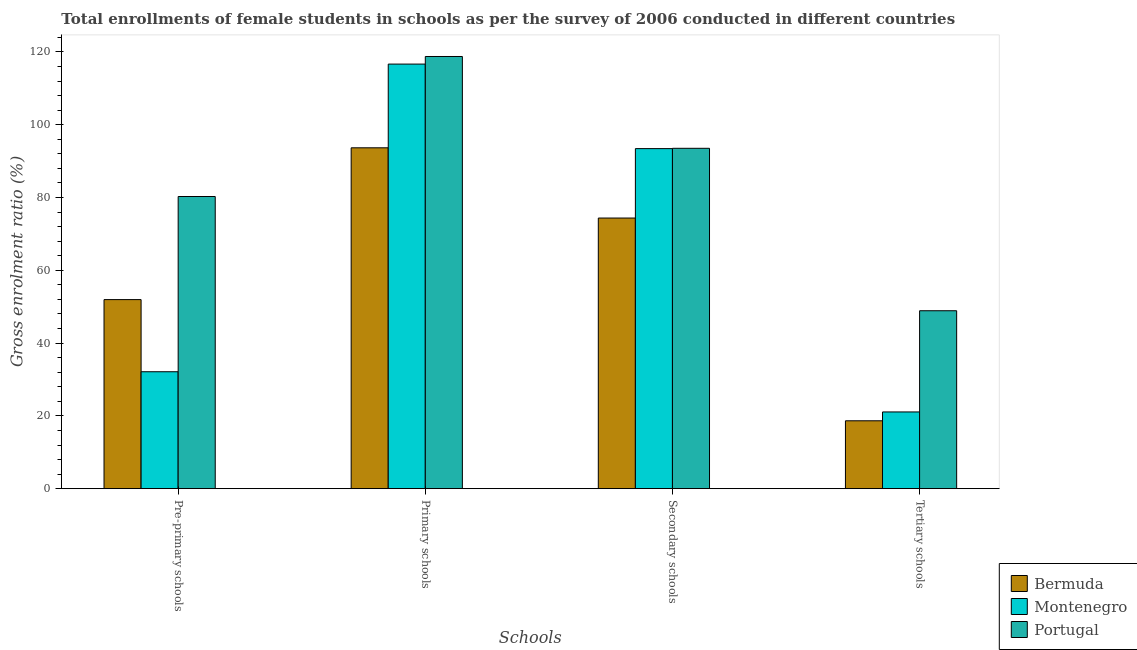How many different coloured bars are there?
Give a very brief answer. 3. How many bars are there on the 1st tick from the right?
Make the answer very short. 3. What is the label of the 2nd group of bars from the left?
Keep it short and to the point. Primary schools. What is the gross enrolment ratio(female) in pre-primary schools in Portugal?
Your response must be concise. 80.28. Across all countries, what is the maximum gross enrolment ratio(female) in pre-primary schools?
Your answer should be very brief. 80.28. Across all countries, what is the minimum gross enrolment ratio(female) in pre-primary schools?
Your answer should be compact. 32.13. In which country was the gross enrolment ratio(female) in pre-primary schools minimum?
Make the answer very short. Montenegro. What is the total gross enrolment ratio(female) in tertiary schools in the graph?
Ensure brevity in your answer.  88.63. What is the difference between the gross enrolment ratio(female) in primary schools in Portugal and that in Bermuda?
Provide a succinct answer. 25.09. What is the difference between the gross enrolment ratio(female) in tertiary schools in Bermuda and the gross enrolment ratio(female) in pre-primary schools in Portugal?
Provide a short and direct response. -61.63. What is the average gross enrolment ratio(female) in secondary schools per country?
Your response must be concise. 87.11. What is the difference between the gross enrolment ratio(female) in primary schools and gross enrolment ratio(female) in tertiary schools in Montenegro?
Your response must be concise. 95.58. In how many countries, is the gross enrolment ratio(female) in primary schools greater than 72 %?
Provide a succinct answer. 3. What is the ratio of the gross enrolment ratio(female) in tertiary schools in Bermuda to that in Montenegro?
Provide a succinct answer. 0.88. What is the difference between the highest and the second highest gross enrolment ratio(female) in tertiary schools?
Ensure brevity in your answer.  27.81. What is the difference between the highest and the lowest gross enrolment ratio(female) in secondary schools?
Make the answer very short. 19.16. In how many countries, is the gross enrolment ratio(female) in primary schools greater than the average gross enrolment ratio(female) in primary schools taken over all countries?
Ensure brevity in your answer.  2. Is the sum of the gross enrolment ratio(female) in tertiary schools in Bermuda and Portugal greater than the maximum gross enrolment ratio(female) in secondary schools across all countries?
Offer a very short reply. No. Is it the case that in every country, the sum of the gross enrolment ratio(female) in pre-primary schools and gross enrolment ratio(female) in secondary schools is greater than the sum of gross enrolment ratio(female) in tertiary schools and gross enrolment ratio(female) in primary schools?
Offer a very short reply. No. What does the 3rd bar from the left in Primary schools represents?
Your answer should be very brief. Portugal. What does the 1st bar from the right in Pre-primary schools represents?
Offer a terse response. Portugal. How many bars are there?
Make the answer very short. 12. Are all the bars in the graph horizontal?
Offer a very short reply. No. How many countries are there in the graph?
Give a very brief answer. 3. What is the difference between two consecutive major ticks on the Y-axis?
Make the answer very short. 20. Does the graph contain any zero values?
Offer a very short reply. No. Where does the legend appear in the graph?
Keep it short and to the point. Bottom right. What is the title of the graph?
Ensure brevity in your answer.  Total enrollments of female students in schools as per the survey of 2006 conducted in different countries. Does "Andorra" appear as one of the legend labels in the graph?
Ensure brevity in your answer.  No. What is the label or title of the X-axis?
Give a very brief answer. Schools. What is the label or title of the Y-axis?
Keep it short and to the point. Gross enrolment ratio (%). What is the Gross enrolment ratio (%) of Bermuda in Pre-primary schools?
Offer a terse response. 51.95. What is the Gross enrolment ratio (%) in Montenegro in Pre-primary schools?
Your answer should be very brief. 32.13. What is the Gross enrolment ratio (%) in Portugal in Pre-primary schools?
Offer a very short reply. 80.28. What is the Gross enrolment ratio (%) in Bermuda in Primary schools?
Make the answer very short. 93.66. What is the Gross enrolment ratio (%) in Montenegro in Primary schools?
Keep it short and to the point. 116.67. What is the Gross enrolment ratio (%) of Portugal in Primary schools?
Provide a succinct answer. 118.76. What is the Gross enrolment ratio (%) of Bermuda in Secondary schools?
Your response must be concise. 74.36. What is the Gross enrolment ratio (%) in Montenegro in Secondary schools?
Offer a very short reply. 93.44. What is the Gross enrolment ratio (%) of Portugal in Secondary schools?
Provide a succinct answer. 93.53. What is the Gross enrolment ratio (%) of Bermuda in Tertiary schools?
Provide a succinct answer. 18.65. What is the Gross enrolment ratio (%) in Montenegro in Tertiary schools?
Make the answer very short. 21.08. What is the Gross enrolment ratio (%) of Portugal in Tertiary schools?
Provide a short and direct response. 48.89. Across all Schools, what is the maximum Gross enrolment ratio (%) in Bermuda?
Your answer should be compact. 93.66. Across all Schools, what is the maximum Gross enrolment ratio (%) in Montenegro?
Keep it short and to the point. 116.67. Across all Schools, what is the maximum Gross enrolment ratio (%) of Portugal?
Give a very brief answer. 118.76. Across all Schools, what is the minimum Gross enrolment ratio (%) of Bermuda?
Offer a very short reply. 18.65. Across all Schools, what is the minimum Gross enrolment ratio (%) in Montenegro?
Provide a short and direct response. 21.08. Across all Schools, what is the minimum Gross enrolment ratio (%) of Portugal?
Provide a short and direct response. 48.89. What is the total Gross enrolment ratio (%) in Bermuda in the graph?
Your answer should be very brief. 238.63. What is the total Gross enrolment ratio (%) of Montenegro in the graph?
Provide a succinct answer. 263.32. What is the total Gross enrolment ratio (%) in Portugal in the graph?
Your answer should be compact. 341.45. What is the difference between the Gross enrolment ratio (%) of Bermuda in Pre-primary schools and that in Primary schools?
Your answer should be compact. -41.71. What is the difference between the Gross enrolment ratio (%) in Montenegro in Pre-primary schools and that in Primary schools?
Your response must be concise. -84.54. What is the difference between the Gross enrolment ratio (%) of Portugal in Pre-primary schools and that in Primary schools?
Provide a succinct answer. -38.47. What is the difference between the Gross enrolment ratio (%) of Bermuda in Pre-primary schools and that in Secondary schools?
Your response must be concise. -22.41. What is the difference between the Gross enrolment ratio (%) of Montenegro in Pre-primary schools and that in Secondary schools?
Ensure brevity in your answer.  -61.31. What is the difference between the Gross enrolment ratio (%) of Portugal in Pre-primary schools and that in Secondary schools?
Offer a very short reply. -13.24. What is the difference between the Gross enrolment ratio (%) of Bermuda in Pre-primary schools and that in Tertiary schools?
Your answer should be compact. 33.3. What is the difference between the Gross enrolment ratio (%) in Montenegro in Pre-primary schools and that in Tertiary schools?
Offer a terse response. 11.04. What is the difference between the Gross enrolment ratio (%) of Portugal in Pre-primary schools and that in Tertiary schools?
Offer a very short reply. 31.39. What is the difference between the Gross enrolment ratio (%) of Bermuda in Primary schools and that in Secondary schools?
Provide a succinct answer. 19.3. What is the difference between the Gross enrolment ratio (%) in Montenegro in Primary schools and that in Secondary schools?
Your answer should be very brief. 23.23. What is the difference between the Gross enrolment ratio (%) in Portugal in Primary schools and that in Secondary schools?
Ensure brevity in your answer.  25.23. What is the difference between the Gross enrolment ratio (%) in Bermuda in Primary schools and that in Tertiary schools?
Keep it short and to the point. 75.01. What is the difference between the Gross enrolment ratio (%) of Montenegro in Primary schools and that in Tertiary schools?
Make the answer very short. 95.58. What is the difference between the Gross enrolment ratio (%) of Portugal in Primary schools and that in Tertiary schools?
Give a very brief answer. 69.86. What is the difference between the Gross enrolment ratio (%) in Bermuda in Secondary schools and that in Tertiary schools?
Your answer should be compact. 55.71. What is the difference between the Gross enrolment ratio (%) of Montenegro in Secondary schools and that in Tertiary schools?
Your answer should be compact. 72.35. What is the difference between the Gross enrolment ratio (%) of Portugal in Secondary schools and that in Tertiary schools?
Ensure brevity in your answer.  44.63. What is the difference between the Gross enrolment ratio (%) of Bermuda in Pre-primary schools and the Gross enrolment ratio (%) of Montenegro in Primary schools?
Offer a terse response. -64.71. What is the difference between the Gross enrolment ratio (%) of Bermuda in Pre-primary schools and the Gross enrolment ratio (%) of Portugal in Primary schools?
Give a very brief answer. -66.8. What is the difference between the Gross enrolment ratio (%) in Montenegro in Pre-primary schools and the Gross enrolment ratio (%) in Portugal in Primary schools?
Your answer should be very brief. -86.63. What is the difference between the Gross enrolment ratio (%) of Bermuda in Pre-primary schools and the Gross enrolment ratio (%) of Montenegro in Secondary schools?
Give a very brief answer. -41.49. What is the difference between the Gross enrolment ratio (%) in Bermuda in Pre-primary schools and the Gross enrolment ratio (%) in Portugal in Secondary schools?
Give a very brief answer. -41.57. What is the difference between the Gross enrolment ratio (%) of Montenegro in Pre-primary schools and the Gross enrolment ratio (%) of Portugal in Secondary schools?
Provide a succinct answer. -61.4. What is the difference between the Gross enrolment ratio (%) in Bermuda in Pre-primary schools and the Gross enrolment ratio (%) in Montenegro in Tertiary schools?
Offer a very short reply. 30.87. What is the difference between the Gross enrolment ratio (%) of Bermuda in Pre-primary schools and the Gross enrolment ratio (%) of Portugal in Tertiary schools?
Ensure brevity in your answer.  3.06. What is the difference between the Gross enrolment ratio (%) of Montenegro in Pre-primary schools and the Gross enrolment ratio (%) of Portugal in Tertiary schools?
Your answer should be very brief. -16.76. What is the difference between the Gross enrolment ratio (%) of Bermuda in Primary schools and the Gross enrolment ratio (%) of Montenegro in Secondary schools?
Ensure brevity in your answer.  0.22. What is the difference between the Gross enrolment ratio (%) of Bermuda in Primary schools and the Gross enrolment ratio (%) of Portugal in Secondary schools?
Give a very brief answer. 0.14. What is the difference between the Gross enrolment ratio (%) of Montenegro in Primary schools and the Gross enrolment ratio (%) of Portugal in Secondary schools?
Offer a very short reply. 23.14. What is the difference between the Gross enrolment ratio (%) of Bermuda in Primary schools and the Gross enrolment ratio (%) of Montenegro in Tertiary schools?
Provide a succinct answer. 72.58. What is the difference between the Gross enrolment ratio (%) in Bermuda in Primary schools and the Gross enrolment ratio (%) in Portugal in Tertiary schools?
Your response must be concise. 44.77. What is the difference between the Gross enrolment ratio (%) of Montenegro in Primary schools and the Gross enrolment ratio (%) of Portugal in Tertiary schools?
Provide a succinct answer. 67.77. What is the difference between the Gross enrolment ratio (%) of Bermuda in Secondary schools and the Gross enrolment ratio (%) of Montenegro in Tertiary schools?
Your response must be concise. 53.28. What is the difference between the Gross enrolment ratio (%) of Bermuda in Secondary schools and the Gross enrolment ratio (%) of Portugal in Tertiary schools?
Make the answer very short. 25.47. What is the difference between the Gross enrolment ratio (%) in Montenegro in Secondary schools and the Gross enrolment ratio (%) in Portugal in Tertiary schools?
Offer a very short reply. 44.55. What is the average Gross enrolment ratio (%) in Bermuda per Schools?
Provide a short and direct response. 59.66. What is the average Gross enrolment ratio (%) of Montenegro per Schools?
Provide a short and direct response. 65.83. What is the average Gross enrolment ratio (%) of Portugal per Schools?
Give a very brief answer. 85.36. What is the difference between the Gross enrolment ratio (%) of Bermuda and Gross enrolment ratio (%) of Montenegro in Pre-primary schools?
Ensure brevity in your answer.  19.82. What is the difference between the Gross enrolment ratio (%) of Bermuda and Gross enrolment ratio (%) of Portugal in Pre-primary schools?
Provide a short and direct response. -28.33. What is the difference between the Gross enrolment ratio (%) in Montenegro and Gross enrolment ratio (%) in Portugal in Pre-primary schools?
Ensure brevity in your answer.  -48.15. What is the difference between the Gross enrolment ratio (%) in Bermuda and Gross enrolment ratio (%) in Montenegro in Primary schools?
Keep it short and to the point. -23. What is the difference between the Gross enrolment ratio (%) in Bermuda and Gross enrolment ratio (%) in Portugal in Primary schools?
Provide a succinct answer. -25.09. What is the difference between the Gross enrolment ratio (%) of Montenegro and Gross enrolment ratio (%) of Portugal in Primary schools?
Your answer should be very brief. -2.09. What is the difference between the Gross enrolment ratio (%) of Bermuda and Gross enrolment ratio (%) of Montenegro in Secondary schools?
Provide a short and direct response. -19.07. What is the difference between the Gross enrolment ratio (%) of Bermuda and Gross enrolment ratio (%) of Portugal in Secondary schools?
Provide a succinct answer. -19.16. What is the difference between the Gross enrolment ratio (%) of Montenegro and Gross enrolment ratio (%) of Portugal in Secondary schools?
Give a very brief answer. -0.09. What is the difference between the Gross enrolment ratio (%) in Bermuda and Gross enrolment ratio (%) in Montenegro in Tertiary schools?
Your answer should be very brief. -2.43. What is the difference between the Gross enrolment ratio (%) in Bermuda and Gross enrolment ratio (%) in Portugal in Tertiary schools?
Your answer should be compact. -30.24. What is the difference between the Gross enrolment ratio (%) in Montenegro and Gross enrolment ratio (%) in Portugal in Tertiary schools?
Your response must be concise. -27.81. What is the ratio of the Gross enrolment ratio (%) of Bermuda in Pre-primary schools to that in Primary schools?
Ensure brevity in your answer.  0.55. What is the ratio of the Gross enrolment ratio (%) in Montenegro in Pre-primary schools to that in Primary schools?
Keep it short and to the point. 0.28. What is the ratio of the Gross enrolment ratio (%) in Portugal in Pre-primary schools to that in Primary schools?
Offer a very short reply. 0.68. What is the ratio of the Gross enrolment ratio (%) of Bermuda in Pre-primary schools to that in Secondary schools?
Ensure brevity in your answer.  0.7. What is the ratio of the Gross enrolment ratio (%) in Montenegro in Pre-primary schools to that in Secondary schools?
Your answer should be compact. 0.34. What is the ratio of the Gross enrolment ratio (%) of Portugal in Pre-primary schools to that in Secondary schools?
Ensure brevity in your answer.  0.86. What is the ratio of the Gross enrolment ratio (%) in Bermuda in Pre-primary schools to that in Tertiary schools?
Provide a short and direct response. 2.79. What is the ratio of the Gross enrolment ratio (%) of Montenegro in Pre-primary schools to that in Tertiary schools?
Provide a short and direct response. 1.52. What is the ratio of the Gross enrolment ratio (%) of Portugal in Pre-primary schools to that in Tertiary schools?
Your response must be concise. 1.64. What is the ratio of the Gross enrolment ratio (%) in Bermuda in Primary schools to that in Secondary schools?
Offer a terse response. 1.26. What is the ratio of the Gross enrolment ratio (%) in Montenegro in Primary schools to that in Secondary schools?
Make the answer very short. 1.25. What is the ratio of the Gross enrolment ratio (%) of Portugal in Primary schools to that in Secondary schools?
Give a very brief answer. 1.27. What is the ratio of the Gross enrolment ratio (%) of Bermuda in Primary schools to that in Tertiary schools?
Keep it short and to the point. 5.02. What is the ratio of the Gross enrolment ratio (%) of Montenegro in Primary schools to that in Tertiary schools?
Provide a succinct answer. 5.53. What is the ratio of the Gross enrolment ratio (%) of Portugal in Primary schools to that in Tertiary schools?
Give a very brief answer. 2.43. What is the ratio of the Gross enrolment ratio (%) of Bermuda in Secondary schools to that in Tertiary schools?
Keep it short and to the point. 3.99. What is the ratio of the Gross enrolment ratio (%) in Montenegro in Secondary schools to that in Tertiary schools?
Your answer should be very brief. 4.43. What is the ratio of the Gross enrolment ratio (%) of Portugal in Secondary schools to that in Tertiary schools?
Offer a terse response. 1.91. What is the difference between the highest and the second highest Gross enrolment ratio (%) of Bermuda?
Keep it short and to the point. 19.3. What is the difference between the highest and the second highest Gross enrolment ratio (%) of Montenegro?
Your response must be concise. 23.23. What is the difference between the highest and the second highest Gross enrolment ratio (%) of Portugal?
Keep it short and to the point. 25.23. What is the difference between the highest and the lowest Gross enrolment ratio (%) in Bermuda?
Offer a terse response. 75.01. What is the difference between the highest and the lowest Gross enrolment ratio (%) of Montenegro?
Your response must be concise. 95.58. What is the difference between the highest and the lowest Gross enrolment ratio (%) in Portugal?
Your response must be concise. 69.86. 